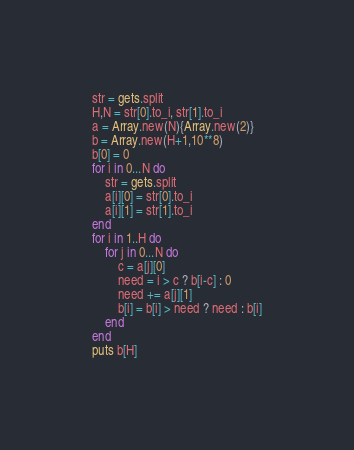<code> <loc_0><loc_0><loc_500><loc_500><_Ruby_>str = gets.split
H,N = str[0].to_i, str[1].to_i
a = Array.new(N){Array.new(2)}
b = Array.new(H+1,10**8)
b[0] = 0
for i in 0...N do
    str = gets.split
    a[i][0] = str[0].to_i
    a[i][1] = str[1].to_i
end
for i in 1..H do
    for j in 0...N do
        c = a[j][0]
        need = i > c ? b[i-c] : 0
        need += a[j][1]
        b[i] = b[i] > need ? need : b[i]
    end
end
puts b[H]</code> 